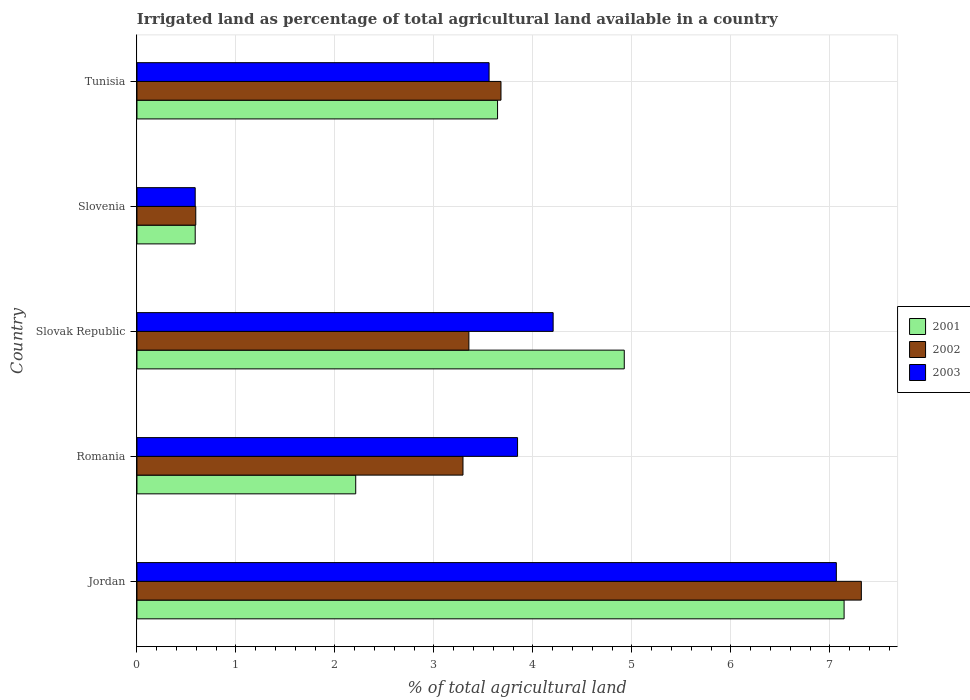How many different coloured bars are there?
Provide a short and direct response. 3. Are the number of bars on each tick of the Y-axis equal?
Your answer should be very brief. Yes. What is the label of the 4th group of bars from the top?
Make the answer very short. Romania. In how many cases, is the number of bars for a given country not equal to the number of legend labels?
Provide a short and direct response. 0. What is the percentage of irrigated land in 2003 in Tunisia?
Your answer should be compact. 3.56. Across all countries, what is the maximum percentage of irrigated land in 2003?
Offer a terse response. 7.06. Across all countries, what is the minimum percentage of irrigated land in 2001?
Your answer should be compact. 0.59. In which country was the percentage of irrigated land in 2001 maximum?
Provide a short and direct response. Jordan. In which country was the percentage of irrigated land in 2003 minimum?
Offer a very short reply. Slovenia. What is the total percentage of irrigated land in 2001 in the graph?
Offer a terse response. 18.51. What is the difference between the percentage of irrigated land in 2003 in Slovenia and that in Tunisia?
Ensure brevity in your answer.  -2.97. What is the difference between the percentage of irrigated land in 2003 in Slovak Republic and the percentage of irrigated land in 2002 in Tunisia?
Provide a short and direct response. 0.53. What is the average percentage of irrigated land in 2001 per country?
Provide a short and direct response. 3.7. What is the difference between the percentage of irrigated land in 2003 and percentage of irrigated land in 2002 in Slovenia?
Ensure brevity in your answer.  -0.01. What is the ratio of the percentage of irrigated land in 2001 in Romania to that in Slovak Republic?
Your answer should be very brief. 0.45. Is the percentage of irrigated land in 2002 in Jordan less than that in Tunisia?
Offer a terse response. No. Is the difference between the percentage of irrigated land in 2003 in Slovak Republic and Tunisia greater than the difference between the percentage of irrigated land in 2002 in Slovak Republic and Tunisia?
Provide a succinct answer. Yes. What is the difference between the highest and the second highest percentage of irrigated land in 2002?
Your response must be concise. 3.64. What is the difference between the highest and the lowest percentage of irrigated land in 2002?
Provide a succinct answer. 6.72. In how many countries, is the percentage of irrigated land in 2001 greater than the average percentage of irrigated land in 2001 taken over all countries?
Offer a very short reply. 2. Is the sum of the percentage of irrigated land in 2001 in Romania and Slovenia greater than the maximum percentage of irrigated land in 2003 across all countries?
Make the answer very short. No. What does the 1st bar from the top in Jordan represents?
Provide a short and direct response. 2003. Are all the bars in the graph horizontal?
Your response must be concise. Yes. How many countries are there in the graph?
Provide a succinct answer. 5. Are the values on the major ticks of X-axis written in scientific E-notation?
Your answer should be very brief. No. Does the graph contain any zero values?
Keep it short and to the point. No. Does the graph contain grids?
Your response must be concise. Yes. How many legend labels are there?
Your answer should be very brief. 3. What is the title of the graph?
Offer a terse response. Irrigated land as percentage of total agricultural land available in a country. Does "2002" appear as one of the legend labels in the graph?
Offer a terse response. Yes. What is the label or title of the X-axis?
Provide a succinct answer. % of total agricultural land. What is the label or title of the Y-axis?
Your answer should be very brief. Country. What is the % of total agricultural land of 2001 in Jordan?
Keep it short and to the point. 7.14. What is the % of total agricultural land of 2002 in Jordan?
Your answer should be compact. 7.32. What is the % of total agricultural land in 2003 in Jordan?
Keep it short and to the point. 7.06. What is the % of total agricultural land of 2001 in Romania?
Offer a terse response. 2.21. What is the % of total agricultural land in 2002 in Romania?
Your answer should be compact. 3.29. What is the % of total agricultural land in 2003 in Romania?
Ensure brevity in your answer.  3.84. What is the % of total agricultural land of 2001 in Slovak Republic?
Provide a short and direct response. 4.92. What is the % of total agricultural land of 2002 in Slovak Republic?
Make the answer very short. 3.35. What is the % of total agricultural land of 2003 in Slovak Republic?
Your answer should be compact. 4.2. What is the % of total agricultural land of 2001 in Slovenia?
Offer a terse response. 0.59. What is the % of total agricultural land in 2002 in Slovenia?
Keep it short and to the point. 0.59. What is the % of total agricultural land of 2003 in Slovenia?
Provide a short and direct response. 0.59. What is the % of total agricultural land of 2001 in Tunisia?
Make the answer very short. 3.64. What is the % of total agricultural land of 2002 in Tunisia?
Your response must be concise. 3.68. What is the % of total agricultural land in 2003 in Tunisia?
Provide a succinct answer. 3.56. Across all countries, what is the maximum % of total agricultural land of 2001?
Ensure brevity in your answer.  7.14. Across all countries, what is the maximum % of total agricultural land in 2002?
Offer a very short reply. 7.32. Across all countries, what is the maximum % of total agricultural land in 2003?
Provide a short and direct response. 7.06. Across all countries, what is the minimum % of total agricultural land of 2001?
Offer a terse response. 0.59. Across all countries, what is the minimum % of total agricultural land of 2002?
Make the answer very short. 0.59. Across all countries, what is the minimum % of total agricultural land of 2003?
Provide a short and direct response. 0.59. What is the total % of total agricultural land in 2001 in the graph?
Offer a terse response. 18.51. What is the total % of total agricultural land in 2002 in the graph?
Your response must be concise. 18.23. What is the total % of total agricultural land in 2003 in the graph?
Provide a short and direct response. 19.26. What is the difference between the % of total agricultural land in 2001 in Jordan and that in Romania?
Provide a short and direct response. 4.93. What is the difference between the % of total agricultural land in 2002 in Jordan and that in Romania?
Make the answer very short. 4.02. What is the difference between the % of total agricultural land of 2003 in Jordan and that in Romania?
Offer a terse response. 3.22. What is the difference between the % of total agricultural land in 2001 in Jordan and that in Slovak Republic?
Offer a terse response. 2.22. What is the difference between the % of total agricultural land of 2002 in Jordan and that in Slovak Republic?
Offer a very short reply. 3.96. What is the difference between the % of total agricultural land in 2003 in Jordan and that in Slovak Republic?
Provide a succinct answer. 2.86. What is the difference between the % of total agricultural land in 2001 in Jordan and that in Slovenia?
Make the answer very short. 6.55. What is the difference between the % of total agricultural land in 2002 in Jordan and that in Slovenia?
Ensure brevity in your answer.  6.72. What is the difference between the % of total agricultural land of 2003 in Jordan and that in Slovenia?
Your answer should be very brief. 6.48. What is the difference between the % of total agricultural land of 2001 in Jordan and that in Tunisia?
Make the answer very short. 3.5. What is the difference between the % of total agricultural land in 2002 in Jordan and that in Tunisia?
Provide a succinct answer. 3.64. What is the difference between the % of total agricultural land in 2003 in Jordan and that in Tunisia?
Offer a terse response. 3.51. What is the difference between the % of total agricultural land in 2001 in Romania and that in Slovak Republic?
Make the answer very short. -2.71. What is the difference between the % of total agricultural land of 2002 in Romania and that in Slovak Republic?
Your response must be concise. -0.06. What is the difference between the % of total agricultural land in 2003 in Romania and that in Slovak Republic?
Make the answer very short. -0.36. What is the difference between the % of total agricultural land in 2001 in Romania and that in Slovenia?
Offer a very short reply. 1.62. What is the difference between the % of total agricultural land of 2002 in Romania and that in Slovenia?
Provide a short and direct response. 2.7. What is the difference between the % of total agricultural land of 2003 in Romania and that in Slovenia?
Provide a succinct answer. 3.26. What is the difference between the % of total agricultural land of 2001 in Romania and that in Tunisia?
Offer a terse response. -1.43. What is the difference between the % of total agricultural land in 2002 in Romania and that in Tunisia?
Your answer should be very brief. -0.38. What is the difference between the % of total agricultural land in 2003 in Romania and that in Tunisia?
Give a very brief answer. 0.29. What is the difference between the % of total agricultural land of 2001 in Slovak Republic and that in Slovenia?
Offer a very short reply. 4.33. What is the difference between the % of total agricultural land in 2002 in Slovak Republic and that in Slovenia?
Give a very brief answer. 2.76. What is the difference between the % of total agricultural land in 2003 in Slovak Republic and that in Slovenia?
Keep it short and to the point. 3.62. What is the difference between the % of total agricultural land of 2001 in Slovak Republic and that in Tunisia?
Give a very brief answer. 1.28. What is the difference between the % of total agricultural land in 2002 in Slovak Republic and that in Tunisia?
Your response must be concise. -0.32. What is the difference between the % of total agricultural land of 2003 in Slovak Republic and that in Tunisia?
Provide a short and direct response. 0.65. What is the difference between the % of total agricultural land in 2001 in Slovenia and that in Tunisia?
Your answer should be compact. -3.05. What is the difference between the % of total agricultural land of 2002 in Slovenia and that in Tunisia?
Offer a very short reply. -3.08. What is the difference between the % of total agricultural land of 2003 in Slovenia and that in Tunisia?
Provide a short and direct response. -2.97. What is the difference between the % of total agricultural land of 2001 in Jordan and the % of total agricultural land of 2002 in Romania?
Your response must be concise. 3.85. What is the difference between the % of total agricultural land in 2001 in Jordan and the % of total agricultural land in 2003 in Romania?
Keep it short and to the point. 3.3. What is the difference between the % of total agricultural land of 2002 in Jordan and the % of total agricultural land of 2003 in Romania?
Provide a succinct answer. 3.47. What is the difference between the % of total agricultural land of 2001 in Jordan and the % of total agricultural land of 2002 in Slovak Republic?
Make the answer very short. 3.79. What is the difference between the % of total agricultural land of 2001 in Jordan and the % of total agricultural land of 2003 in Slovak Republic?
Make the answer very short. 2.94. What is the difference between the % of total agricultural land of 2002 in Jordan and the % of total agricultural land of 2003 in Slovak Republic?
Provide a short and direct response. 3.11. What is the difference between the % of total agricultural land in 2001 in Jordan and the % of total agricultural land in 2002 in Slovenia?
Make the answer very short. 6.55. What is the difference between the % of total agricultural land of 2001 in Jordan and the % of total agricultural land of 2003 in Slovenia?
Your answer should be very brief. 6.55. What is the difference between the % of total agricultural land in 2002 in Jordan and the % of total agricultural land in 2003 in Slovenia?
Your response must be concise. 6.73. What is the difference between the % of total agricultural land of 2001 in Jordan and the % of total agricultural land of 2002 in Tunisia?
Make the answer very short. 3.47. What is the difference between the % of total agricultural land in 2001 in Jordan and the % of total agricultural land in 2003 in Tunisia?
Make the answer very short. 3.59. What is the difference between the % of total agricultural land in 2002 in Jordan and the % of total agricultural land in 2003 in Tunisia?
Provide a short and direct response. 3.76. What is the difference between the % of total agricultural land in 2001 in Romania and the % of total agricultural land in 2002 in Slovak Republic?
Your answer should be very brief. -1.14. What is the difference between the % of total agricultural land of 2001 in Romania and the % of total agricultural land of 2003 in Slovak Republic?
Offer a very short reply. -1.99. What is the difference between the % of total agricultural land of 2002 in Romania and the % of total agricultural land of 2003 in Slovak Republic?
Offer a very short reply. -0.91. What is the difference between the % of total agricultural land of 2001 in Romania and the % of total agricultural land of 2002 in Slovenia?
Provide a short and direct response. 1.62. What is the difference between the % of total agricultural land of 2001 in Romania and the % of total agricultural land of 2003 in Slovenia?
Make the answer very short. 1.62. What is the difference between the % of total agricultural land in 2002 in Romania and the % of total agricultural land in 2003 in Slovenia?
Keep it short and to the point. 2.71. What is the difference between the % of total agricultural land of 2001 in Romania and the % of total agricultural land of 2002 in Tunisia?
Your response must be concise. -1.47. What is the difference between the % of total agricultural land in 2001 in Romania and the % of total agricultural land in 2003 in Tunisia?
Make the answer very short. -1.35. What is the difference between the % of total agricultural land in 2002 in Romania and the % of total agricultural land in 2003 in Tunisia?
Provide a short and direct response. -0.26. What is the difference between the % of total agricultural land of 2001 in Slovak Republic and the % of total agricultural land of 2002 in Slovenia?
Offer a very short reply. 4.33. What is the difference between the % of total agricultural land of 2001 in Slovak Republic and the % of total agricultural land of 2003 in Slovenia?
Provide a short and direct response. 4.33. What is the difference between the % of total agricultural land in 2002 in Slovak Republic and the % of total agricultural land in 2003 in Slovenia?
Make the answer very short. 2.76. What is the difference between the % of total agricultural land in 2001 in Slovak Republic and the % of total agricultural land in 2002 in Tunisia?
Your answer should be very brief. 1.25. What is the difference between the % of total agricultural land of 2001 in Slovak Republic and the % of total agricultural land of 2003 in Tunisia?
Your answer should be very brief. 1.37. What is the difference between the % of total agricultural land of 2002 in Slovak Republic and the % of total agricultural land of 2003 in Tunisia?
Give a very brief answer. -0.2. What is the difference between the % of total agricultural land in 2001 in Slovenia and the % of total agricultural land in 2002 in Tunisia?
Keep it short and to the point. -3.09. What is the difference between the % of total agricultural land of 2001 in Slovenia and the % of total agricultural land of 2003 in Tunisia?
Ensure brevity in your answer.  -2.97. What is the difference between the % of total agricultural land in 2002 in Slovenia and the % of total agricultural land in 2003 in Tunisia?
Offer a terse response. -2.96. What is the average % of total agricultural land in 2001 per country?
Offer a terse response. 3.7. What is the average % of total agricultural land of 2002 per country?
Ensure brevity in your answer.  3.65. What is the average % of total agricultural land of 2003 per country?
Offer a terse response. 3.85. What is the difference between the % of total agricultural land of 2001 and % of total agricultural land of 2002 in Jordan?
Provide a short and direct response. -0.17. What is the difference between the % of total agricultural land of 2001 and % of total agricultural land of 2003 in Jordan?
Offer a very short reply. 0.08. What is the difference between the % of total agricultural land in 2002 and % of total agricultural land in 2003 in Jordan?
Ensure brevity in your answer.  0.25. What is the difference between the % of total agricultural land in 2001 and % of total agricultural land in 2002 in Romania?
Offer a terse response. -1.08. What is the difference between the % of total agricultural land of 2001 and % of total agricultural land of 2003 in Romania?
Give a very brief answer. -1.63. What is the difference between the % of total agricultural land in 2002 and % of total agricultural land in 2003 in Romania?
Provide a succinct answer. -0.55. What is the difference between the % of total agricultural land in 2001 and % of total agricultural land in 2002 in Slovak Republic?
Ensure brevity in your answer.  1.57. What is the difference between the % of total agricultural land of 2001 and % of total agricultural land of 2003 in Slovak Republic?
Your response must be concise. 0.72. What is the difference between the % of total agricultural land of 2002 and % of total agricultural land of 2003 in Slovak Republic?
Make the answer very short. -0.85. What is the difference between the % of total agricultural land of 2001 and % of total agricultural land of 2002 in Slovenia?
Provide a succinct answer. -0.01. What is the difference between the % of total agricultural land in 2002 and % of total agricultural land in 2003 in Slovenia?
Offer a very short reply. 0.01. What is the difference between the % of total agricultural land in 2001 and % of total agricultural land in 2002 in Tunisia?
Make the answer very short. -0.03. What is the difference between the % of total agricultural land in 2001 and % of total agricultural land in 2003 in Tunisia?
Your answer should be very brief. 0.09. What is the difference between the % of total agricultural land of 2002 and % of total agricultural land of 2003 in Tunisia?
Offer a terse response. 0.12. What is the ratio of the % of total agricultural land in 2001 in Jordan to that in Romania?
Offer a terse response. 3.23. What is the ratio of the % of total agricultural land in 2002 in Jordan to that in Romania?
Provide a succinct answer. 2.22. What is the ratio of the % of total agricultural land of 2003 in Jordan to that in Romania?
Give a very brief answer. 1.84. What is the ratio of the % of total agricultural land of 2001 in Jordan to that in Slovak Republic?
Give a very brief answer. 1.45. What is the ratio of the % of total agricultural land in 2002 in Jordan to that in Slovak Republic?
Provide a short and direct response. 2.18. What is the ratio of the % of total agricultural land in 2003 in Jordan to that in Slovak Republic?
Your response must be concise. 1.68. What is the ratio of the % of total agricultural land in 2001 in Jordan to that in Slovenia?
Offer a terse response. 12.14. What is the ratio of the % of total agricultural land in 2002 in Jordan to that in Slovenia?
Your answer should be compact. 12.32. What is the ratio of the % of total agricultural land of 2003 in Jordan to that in Slovenia?
Make the answer very short. 12.01. What is the ratio of the % of total agricultural land in 2001 in Jordan to that in Tunisia?
Your response must be concise. 1.96. What is the ratio of the % of total agricultural land in 2002 in Jordan to that in Tunisia?
Your answer should be very brief. 1.99. What is the ratio of the % of total agricultural land of 2003 in Jordan to that in Tunisia?
Your answer should be compact. 1.99. What is the ratio of the % of total agricultural land in 2001 in Romania to that in Slovak Republic?
Ensure brevity in your answer.  0.45. What is the ratio of the % of total agricultural land in 2002 in Romania to that in Slovak Republic?
Make the answer very short. 0.98. What is the ratio of the % of total agricultural land in 2003 in Romania to that in Slovak Republic?
Ensure brevity in your answer.  0.91. What is the ratio of the % of total agricultural land in 2001 in Romania to that in Slovenia?
Give a very brief answer. 3.76. What is the ratio of the % of total agricultural land in 2002 in Romania to that in Slovenia?
Give a very brief answer. 5.54. What is the ratio of the % of total agricultural land in 2003 in Romania to that in Slovenia?
Your answer should be very brief. 6.54. What is the ratio of the % of total agricultural land in 2001 in Romania to that in Tunisia?
Offer a terse response. 0.61. What is the ratio of the % of total agricultural land of 2002 in Romania to that in Tunisia?
Ensure brevity in your answer.  0.9. What is the ratio of the % of total agricultural land of 2003 in Romania to that in Tunisia?
Your answer should be very brief. 1.08. What is the ratio of the % of total agricultural land in 2001 in Slovak Republic to that in Slovenia?
Offer a terse response. 8.37. What is the ratio of the % of total agricultural land of 2002 in Slovak Republic to that in Slovenia?
Your answer should be compact. 5.64. What is the ratio of the % of total agricultural land of 2003 in Slovak Republic to that in Slovenia?
Provide a succinct answer. 7.15. What is the ratio of the % of total agricultural land in 2001 in Slovak Republic to that in Tunisia?
Provide a succinct answer. 1.35. What is the ratio of the % of total agricultural land in 2002 in Slovak Republic to that in Tunisia?
Provide a succinct answer. 0.91. What is the ratio of the % of total agricultural land of 2003 in Slovak Republic to that in Tunisia?
Your answer should be compact. 1.18. What is the ratio of the % of total agricultural land in 2001 in Slovenia to that in Tunisia?
Give a very brief answer. 0.16. What is the ratio of the % of total agricultural land in 2002 in Slovenia to that in Tunisia?
Offer a terse response. 0.16. What is the ratio of the % of total agricultural land in 2003 in Slovenia to that in Tunisia?
Ensure brevity in your answer.  0.17. What is the difference between the highest and the second highest % of total agricultural land of 2001?
Ensure brevity in your answer.  2.22. What is the difference between the highest and the second highest % of total agricultural land in 2002?
Offer a very short reply. 3.64. What is the difference between the highest and the second highest % of total agricultural land of 2003?
Your answer should be compact. 2.86. What is the difference between the highest and the lowest % of total agricultural land in 2001?
Provide a short and direct response. 6.55. What is the difference between the highest and the lowest % of total agricultural land of 2002?
Ensure brevity in your answer.  6.72. What is the difference between the highest and the lowest % of total agricultural land in 2003?
Make the answer very short. 6.48. 